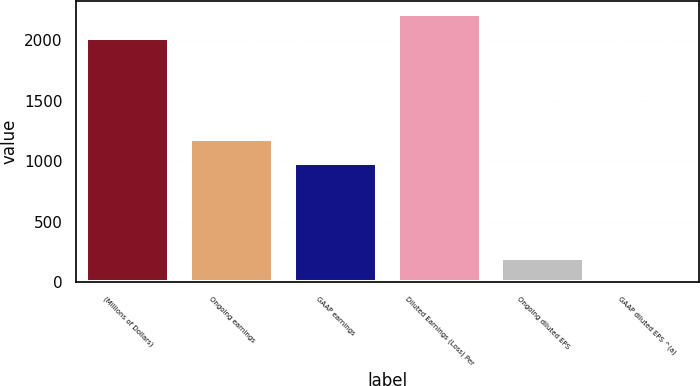<chart> <loc_0><loc_0><loc_500><loc_500><bar_chart><fcel>(Millions of Dollars)<fcel>Ongoing earnings<fcel>GAAP earnings<fcel>Diluted Earnings (Loss) Per<fcel>Ongoing diluted EPS<fcel>GAAP diluted EPS ^(a)<nl><fcel>2015<fcel>1185.81<fcel>984.5<fcel>2216.31<fcel>203.25<fcel>1.94<nl></chart> 